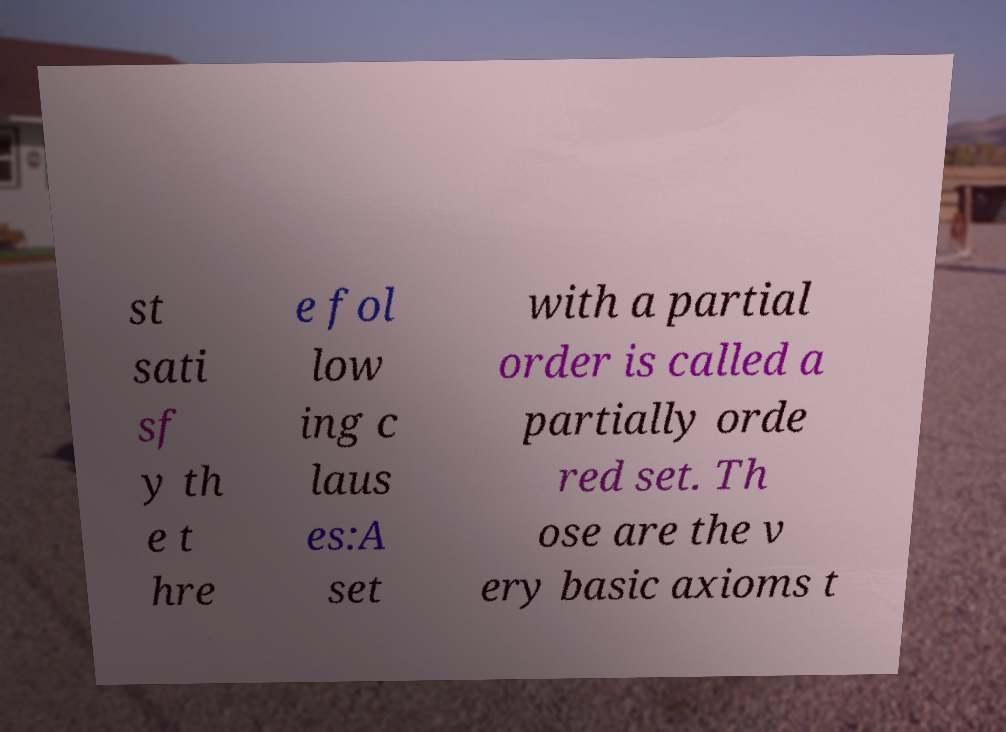There's text embedded in this image that I need extracted. Can you transcribe it verbatim? st sati sf y th e t hre e fol low ing c laus es:A set with a partial order is called a partially orde red set. Th ose are the v ery basic axioms t 